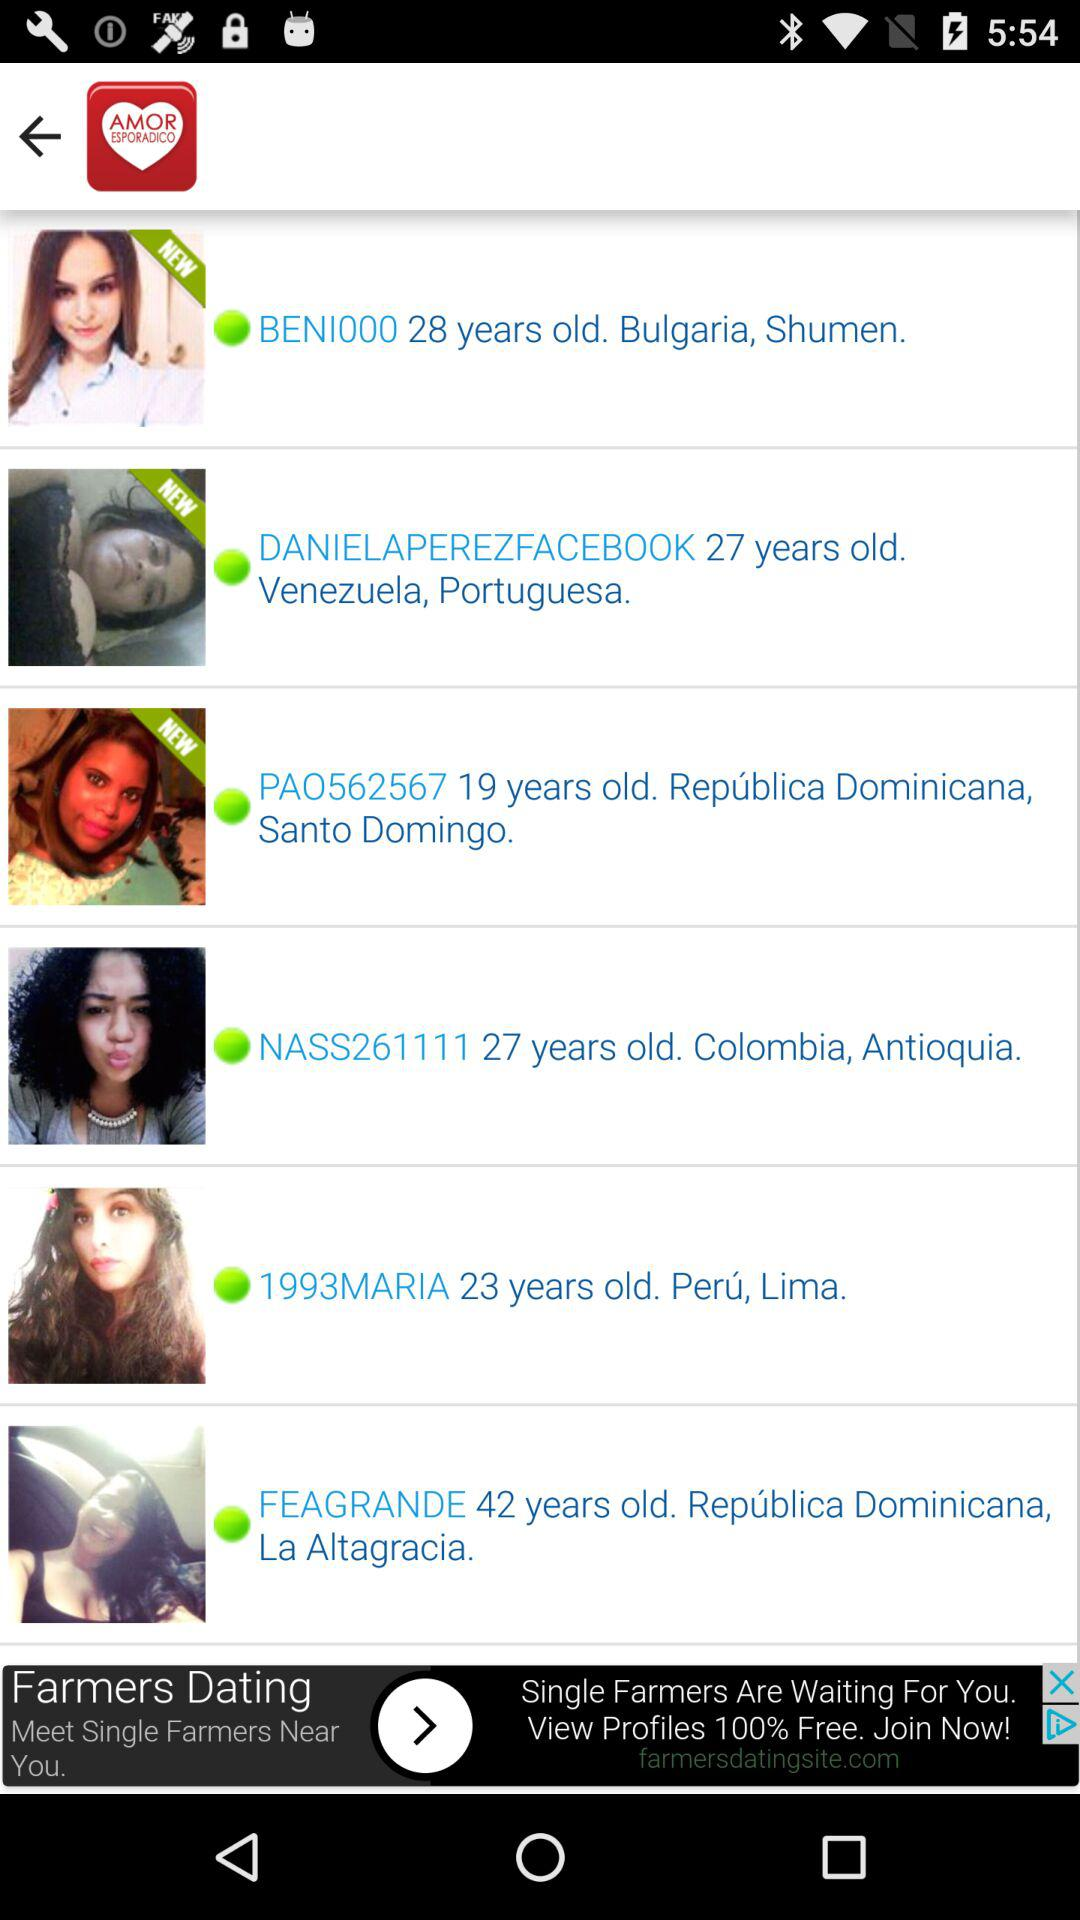Which user has the age of 42 years? The user that has the age of 42 years is "FEAGRANDE". 